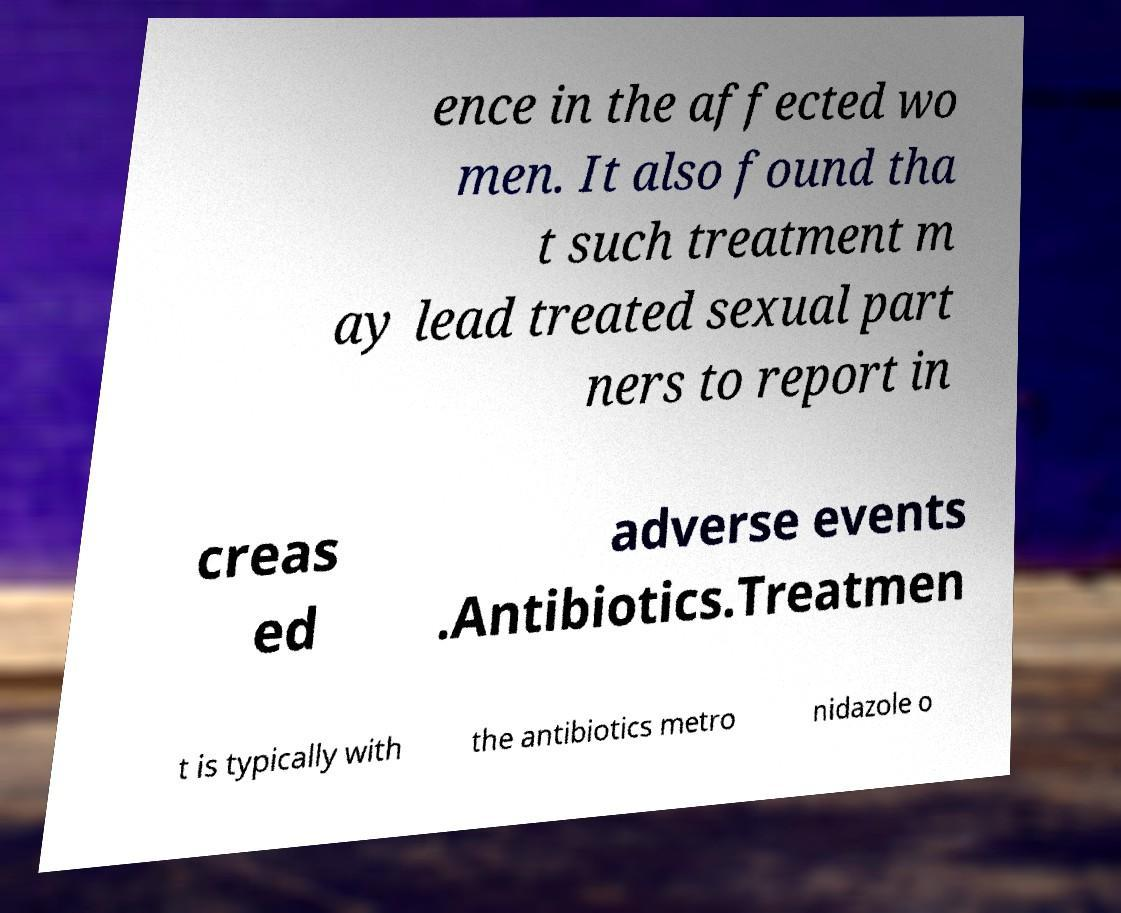There's text embedded in this image that I need extracted. Can you transcribe it verbatim? ence in the affected wo men. It also found tha t such treatment m ay lead treated sexual part ners to report in creas ed adverse events .Antibiotics.Treatmen t is typically with the antibiotics metro nidazole o 